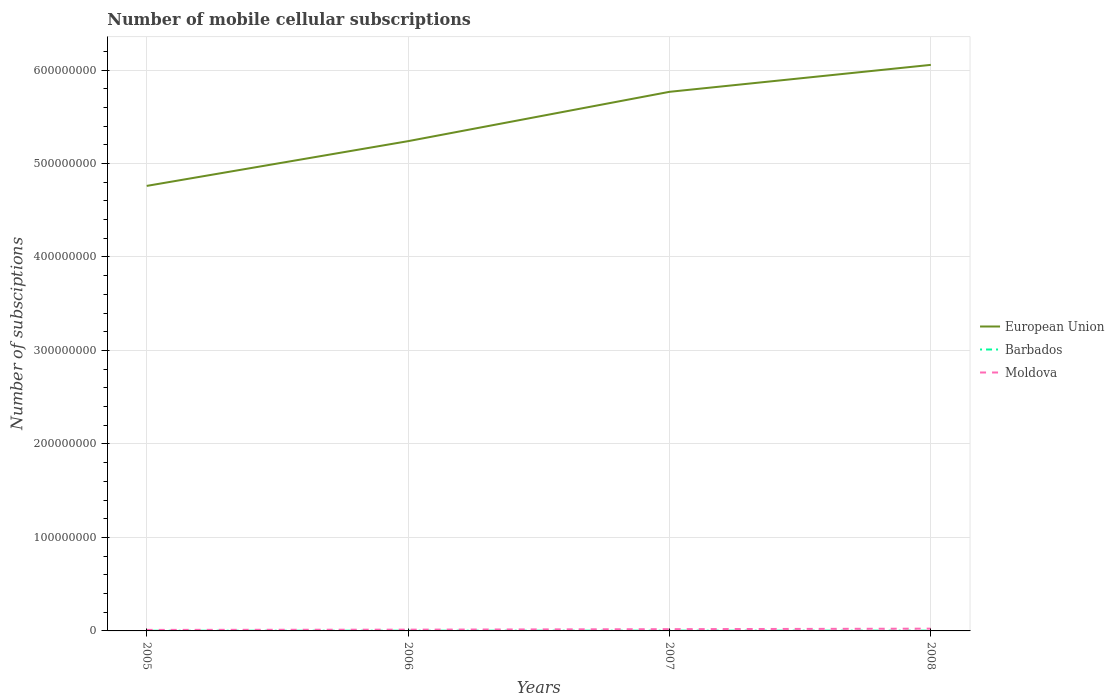How many different coloured lines are there?
Offer a very short reply. 3. Does the line corresponding to Moldova intersect with the line corresponding to Barbados?
Keep it short and to the point. No. Is the number of lines equal to the number of legend labels?
Ensure brevity in your answer.  Yes. Across all years, what is the maximum number of mobile cellular subscriptions in Moldova?
Keep it short and to the point. 1.09e+06. What is the total number of mobile cellular subscriptions in Moldova in the graph?
Make the answer very short. -5.25e+05. What is the difference between the highest and the second highest number of mobile cellular subscriptions in Barbados?
Make the answer very short. 8.25e+04. What is the difference between the highest and the lowest number of mobile cellular subscriptions in European Union?
Your answer should be compact. 2. How many lines are there?
Offer a terse response. 3. Where does the legend appear in the graph?
Your answer should be compact. Center right. How many legend labels are there?
Provide a succinct answer. 3. What is the title of the graph?
Ensure brevity in your answer.  Number of mobile cellular subscriptions. Does "Latvia" appear as one of the legend labels in the graph?
Offer a very short reply. No. What is the label or title of the X-axis?
Offer a terse response. Years. What is the label or title of the Y-axis?
Your answer should be compact. Number of subsciptions. What is the Number of subsciptions of European Union in 2005?
Your answer should be very brief. 4.76e+08. What is the Number of subsciptions of Barbados in 2005?
Offer a terse response. 2.06e+05. What is the Number of subsciptions in Moldova in 2005?
Provide a succinct answer. 1.09e+06. What is the Number of subsciptions in European Union in 2006?
Your response must be concise. 5.24e+08. What is the Number of subsciptions of Barbados in 2006?
Your answer should be very brief. 2.37e+05. What is the Number of subsciptions in Moldova in 2006?
Your answer should be very brief. 1.36e+06. What is the Number of subsciptions in European Union in 2007?
Your response must be concise. 5.77e+08. What is the Number of subsciptions in Barbados in 2007?
Make the answer very short. 2.58e+05. What is the Number of subsciptions of Moldova in 2007?
Offer a terse response. 1.88e+06. What is the Number of subsciptions of European Union in 2008?
Make the answer very short. 6.05e+08. What is the Number of subsciptions of Barbados in 2008?
Provide a succinct answer. 2.89e+05. What is the Number of subsciptions of Moldova in 2008?
Provide a succinct answer. 2.42e+06. Across all years, what is the maximum Number of subsciptions in European Union?
Keep it short and to the point. 6.05e+08. Across all years, what is the maximum Number of subsciptions of Barbados?
Offer a terse response. 2.89e+05. Across all years, what is the maximum Number of subsciptions of Moldova?
Provide a short and direct response. 2.42e+06. Across all years, what is the minimum Number of subsciptions in European Union?
Provide a short and direct response. 4.76e+08. Across all years, what is the minimum Number of subsciptions in Barbados?
Your answer should be compact. 2.06e+05. Across all years, what is the minimum Number of subsciptions of Moldova?
Your answer should be very brief. 1.09e+06. What is the total Number of subsciptions of European Union in the graph?
Your response must be concise. 2.18e+09. What is the total Number of subsciptions of Barbados in the graph?
Keep it short and to the point. 9.90e+05. What is the total Number of subsciptions in Moldova in the graph?
Provide a short and direct response. 6.75e+06. What is the difference between the Number of subsciptions of European Union in 2005 and that in 2006?
Keep it short and to the point. -4.79e+07. What is the difference between the Number of subsciptions of Barbados in 2005 and that in 2006?
Provide a succinct answer. -3.09e+04. What is the difference between the Number of subsciptions of Moldova in 2005 and that in 2006?
Provide a succinct answer. -2.68e+05. What is the difference between the Number of subsciptions in European Union in 2005 and that in 2007?
Give a very brief answer. -1.01e+08. What is the difference between the Number of subsciptions of Barbados in 2005 and that in 2007?
Keep it short and to the point. -5.14e+04. What is the difference between the Number of subsciptions of Moldova in 2005 and that in 2007?
Make the answer very short. -7.93e+05. What is the difference between the Number of subsciptions in European Union in 2005 and that in 2008?
Make the answer very short. -1.29e+08. What is the difference between the Number of subsciptions in Barbados in 2005 and that in 2008?
Provide a short and direct response. -8.25e+04. What is the difference between the Number of subsciptions of Moldova in 2005 and that in 2008?
Keep it short and to the point. -1.33e+06. What is the difference between the Number of subsciptions of European Union in 2006 and that in 2007?
Provide a succinct answer. -5.28e+07. What is the difference between the Number of subsciptions in Barbados in 2006 and that in 2007?
Give a very brief answer. -2.05e+04. What is the difference between the Number of subsciptions of Moldova in 2006 and that in 2007?
Your answer should be compact. -5.25e+05. What is the difference between the Number of subsciptions of European Union in 2006 and that in 2008?
Keep it short and to the point. -8.16e+07. What is the difference between the Number of subsciptions in Barbados in 2006 and that in 2008?
Your answer should be compact. -5.15e+04. What is the difference between the Number of subsciptions in Moldova in 2006 and that in 2008?
Give a very brief answer. -1.07e+06. What is the difference between the Number of subsciptions in European Union in 2007 and that in 2008?
Make the answer very short. -2.88e+07. What is the difference between the Number of subsciptions in Barbados in 2007 and that in 2008?
Your response must be concise. -3.11e+04. What is the difference between the Number of subsciptions of Moldova in 2007 and that in 2008?
Give a very brief answer. -5.41e+05. What is the difference between the Number of subsciptions in European Union in 2005 and the Number of subsciptions in Barbados in 2006?
Make the answer very short. 4.76e+08. What is the difference between the Number of subsciptions in European Union in 2005 and the Number of subsciptions in Moldova in 2006?
Offer a terse response. 4.75e+08. What is the difference between the Number of subsciptions in Barbados in 2005 and the Number of subsciptions in Moldova in 2006?
Offer a very short reply. -1.15e+06. What is the difference between the Number of subsciptions of European Union in 2005 and the Number of subsciptions of Barbados in 2007?
Your response must be concise. 4.76e+08. What is the difference between the Number of subsciptions of European Union in 2005 and the Number of subsciptions of Moldova in 2007?
Provide a short and direct response. 4.74e+08. What is the difference between the Number of subsciptions of Barbados in 2005 and the Number of subsciptions of Moldova in 2007?
Give a very brief answer. -1.68e+06. What is the difference between the Number of subsciptions of European Union in 2005 and the Number of subsciptions of Barbados in 2008?
Keep it short and to the point. 4.76e+08. What is the difference between the Number of subsciptions in European Union in 2005 and the Number of subsciptions in Moldova in 2008?
Your answer should be very brief. 4.74e+08. What is the difference between the Number of subsciptions of Barbados in 2005 and the Number of subsciptions of Moldova in 2008?
Your response must be concise. -2.22e+06. What is the difference between the Number of subsciptions in European Union in 2006 and the Number of subsciptions in Barbados in 2007?
Make the answer very short. 5.24e+08. What is the difference between the Number of subsciptions of European Union in 2006 and the Number of subsciptions of Moldova in 2007?
Your answer should be compact. 5.22e+08. What is the difference between the Number of subsciptions in Barbados in 2006 and the Number of subsciptions in Moldova in 2007?
Offer a terse response. -1.65e+06. What is the difference between the Number of subsciptions in European Union in 2006 and the Number of subsciptions in Barbados in 2008?
Your answer should be compact. 5.24e+08. What is the difference between the Number of subsciptions of European Union in 2006 and the Number of subsciptions of Moldova in 2008?
Provide a short and direct response. 5.21e+08. What is the difference between the Number of subsciptions in Barbados in 2006 and the Number of subsciptions in Moldova in 2008?
Offer a very short reply. -2.19e+06. What is the difference between the Number of subsciptions in European Union in 2007 and the Number of subsciptions in Barbados in 2008?
Provide a succinct answer. 5.76e+08. What is the difference between the Number of subsciptions of European Union in 2007 and the Number of subsciptions of Moldova in 2008?
Your response must be concise. 5.74e+08. What is the difference between the Number of subsciptions of Barbados in 2007 and the Number of subsciptions of Moldova in 2008?
Give a very brief answer. -2.17e+06. What is the average Number of subsciptions in European Union per year?
Offer a very short reply. 5.46e+08. What is the average Number of subsciptions in Barbados per year?
Your answer should be very brief. 2.47e+05. What is the average Number of subsciptions in Moldova per year?
Give a very brief answer. 1.69e+06. In the year 2005, what is the difference between the Number of subsciptions in European Union and Number of subsciptions in Barbados?
Offer a very short reply. 4.76e+08. In the year 2005, what is the difference between the Number of subsciptions of European Union and Number of subsciptions of Moldova?
Give a very brief answer. 4.75e+08. In the year 2005, what is the difference between the Number of subsciptions in Barbados and Number of subsciptions in Moldova?
Ensure brevity in your answer.  -8.84e+05. In the year 2006, what is the difference between the Number of subsciptions of European Union and Number of subsciptions of Barbados?
Your response must be concise. 5.24e+08. In the year 2006, what is the difference between the Number of subsciptions in European Union and Number of subsciptions in Moldova?
Offer a terse response. 5.23e+08. In the year 2006, what is the difference between the Number of subsciptions in Barbados and Number of subsciptions in Moldova?
Provide a succinct answer. -1.12e+06. In the year 2007, what is the difference between the Number of subsciptions of European Union and Number of subsciptions of Barbados?
Ensure brevity in your answer.  5.76e+08. In the year 2007, what is the difference between the Number of subsciptions in European Union and Number of subsciptions in Moldova?
Give a very brief answer. 5.75e+08. In the year 2007, what is the difference between the Number of subsciptions of Barbados and Number of subsciptions of Moldova?
Your response must be concise. -1.63e+06. In the year 2008, what is the difference between the Number of subsciptions in European Union and Number of subsciptions in Barbados?
Your response must be concise. 6.05e+08. In the year 2008, what is the difference between the Number of subsciptions in European Union and Number of subsciptions in Moldova?
Provide a short and direct response. 6.03e+08. In the year 2008, what is the difference between the Number of subsciptions in Barbados and Number of subsciptions in Moldova?
Offer a very short reply. -2.13e+06. What is the ratio of the Number of subsciptions in European Union in 2005 to that in 2006?
Offer a terse response. 0.91. What is the ratio of the Number of subsciptions of Barbados in 2005 to that in 2006?
Keep it short and to the point. 0.87. What is the ratio of the Number of subsciptions in Moldova in 2005 to that in 2006?
Keep it short and to the point. 0.8. What is the ratio of the Number of subsciptions in European Union in 2005 to that in 2007?
Your answer should be compact. 0.83. What is the ratio of the Number of subsciptions of Barbados in 2005 to that in 2007?
Offer a terse response. 0.8. What is the ratio of the Number of subsciptions in Moldova in 2005 to that in 2007?
Offer a terse response. 0.58. What is the ratio of the Number of subsciptions in European Union in 2005 to that in 2008?
Your answer should be very brief. 0.79. What is the ratio of the Number of subsciptions in Barbados in 2005 to that in 2008?
Your response must be concise. 0.71. What is the ratio of the Number of subsciptions of Moldova in 2005 to that in 2008?
Give a very brief answer. 0.45. What is the ratio of the Number of subsciptions in European Union in 2006 to that in 2007?
Your answer should be very brief. 0.91. What is the ratio of the Number of subsciptions of Barbados in 2006 to that in 2007?
Your response must be concise. 0.92. What is the ratio of the Number of subsciptions in Moldova in 2006 to that in 2007?
Ensure brevity in your answer.  0.72. What is the ratio of the Number of subsciptions of European Union in 2006 to that in 2008?
Keep it short and to the point. 0.87. What is the ratio of the Number of subsciptions of Barbados in 2006 to that in 2008?
Offer a terse response. 0.82. What is the ratio of the Number of subsciptions in Moldova in 2006 to that in 2008?
Offer a very short reply. 0.56. What is the ratio of the Number of subsciptions of European Union in 2007 to that in 2008?
Ensure brevity in your answer.  0.95. What is the ratio of the Number of subsciptions of Barbados in 2007 to that in 2008?
Provide a short and direct response. 0.89. What is the ratio of the Number of subsciptions in Moldova in 2007 to that in 2008?
Give a very brief answer. 0.78. What is the difference between the highest and the second highest Number of subsciptions of European Union?
Keep it short and to the point. 2.88e+07. What is the difference between the highest and the second highest Number of subsciptions of Barbados?
Your answer should be compact. 3.11e+04. What is the difference between the highest and the second highest Number of subsciptions in Moldova?
Offer a very short reply. 5.41e+05. What is the difference between the highest and the lowest Number of subsciptions in European Union?
Make the answer very short. 1.29e+08. What is the difference between the highest and the lowest Number of subsciptions of Barbados?
Your response must be concise. 8.25e+04. What is the difference between the highest and the lowest Number of subsciptions in Moldova?
Offer a very short reply. 1.33e+06. 